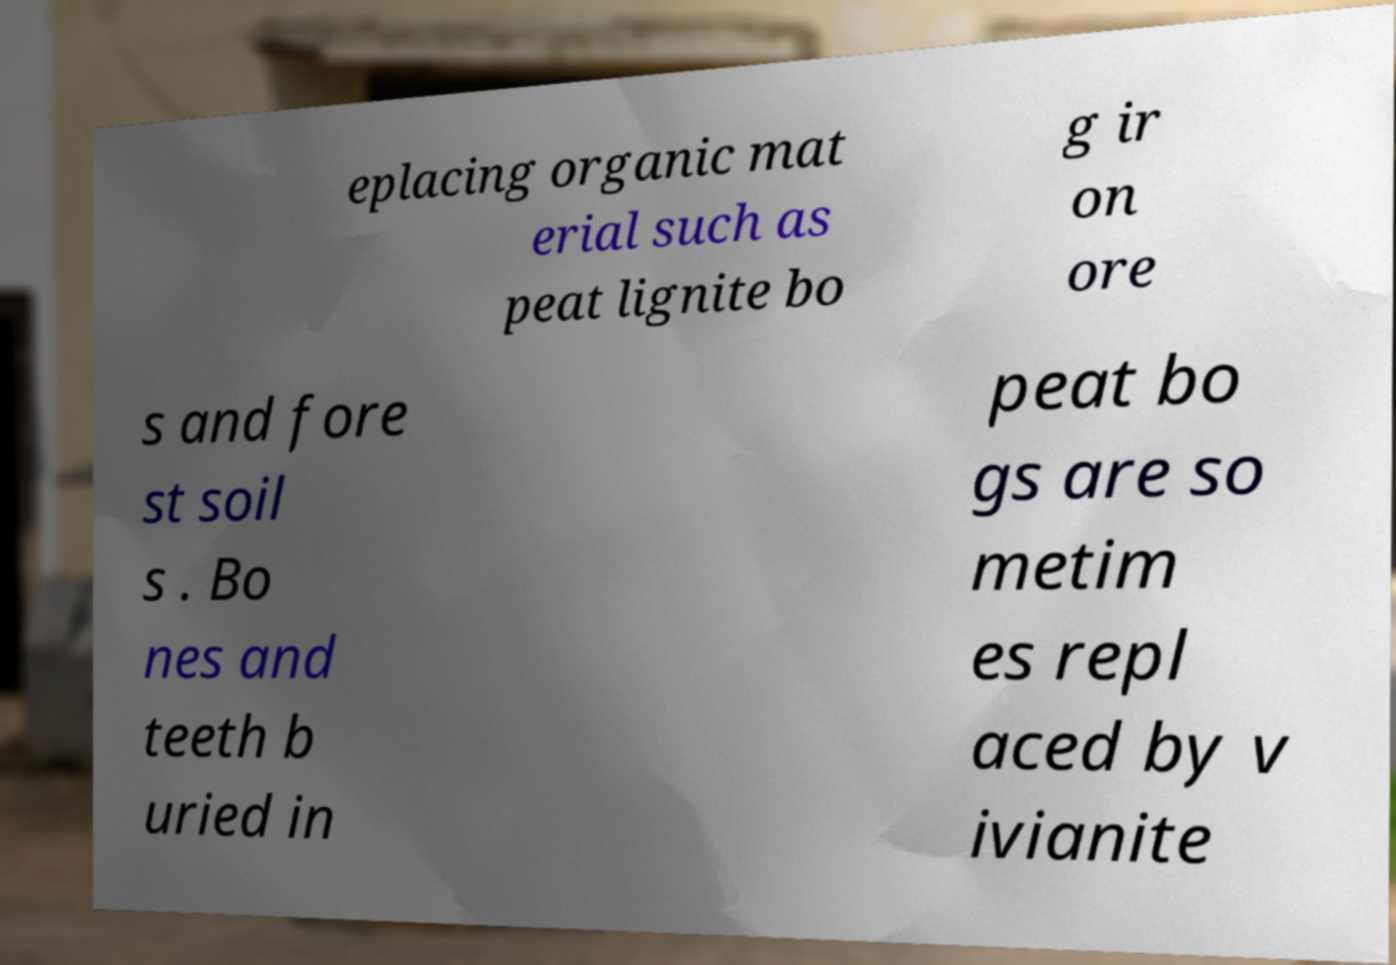I need the written content from this picture converted into text. Can you do that? eplacing organic mat erial such as peat lignite bo g ir on ore s and fore st soil s . Bo nes and teeth b uried in peat bo gs are so metim es repl aced by v ivianite 